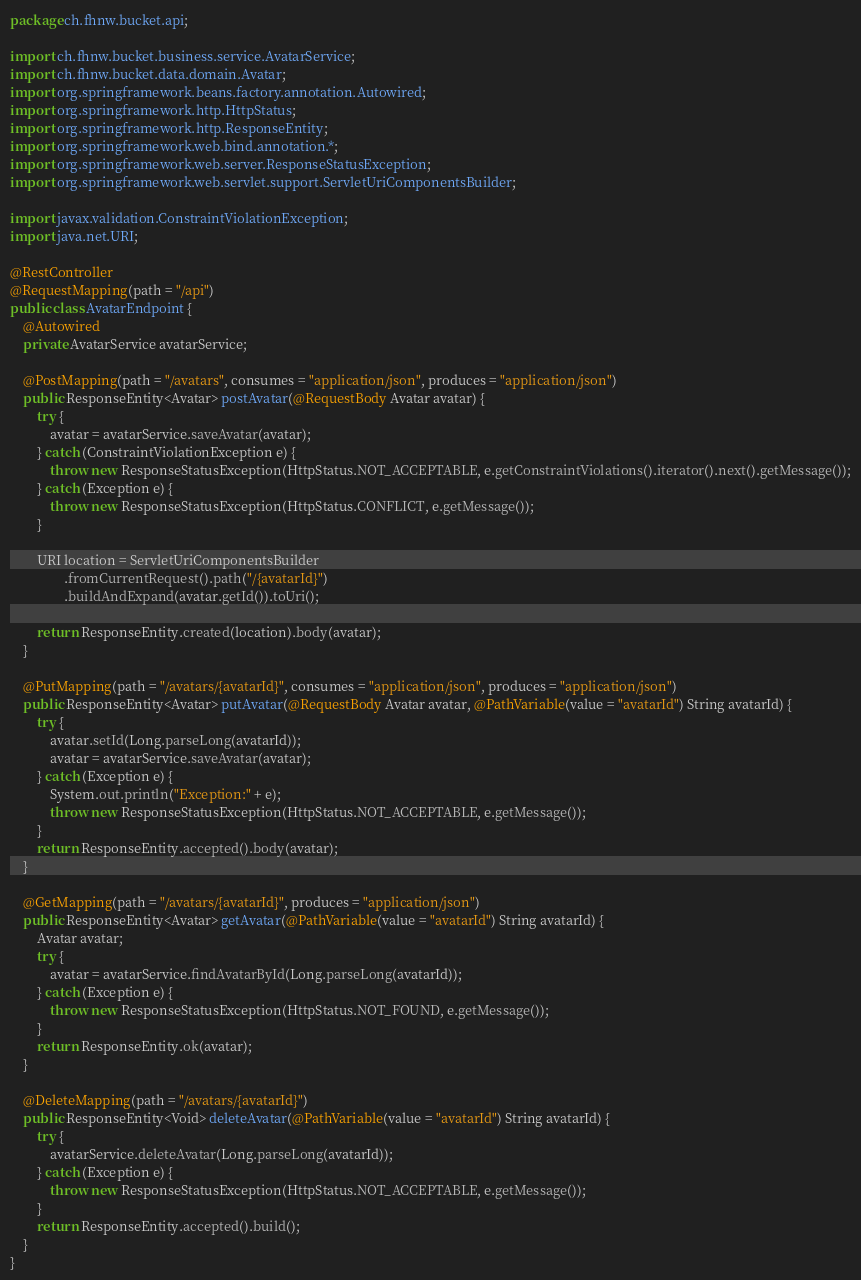<code> <loc_0><loc_0><loc_500><loc_500><_Java_>package ch.fhnw.bucket.api;

import ch.fhnw.bucket.business.service.AvatarService;
import ch.fhnw.bucket.data.domain.Avatar;
import org.springframework.beans.factory.annotation.Autowired;
import org.springframework.http.HttpStatus;
import org.springframework.http.ResponseEntity;
import org.springframework.web.bind.annotation.*;
import org.springframework.web.server.ResponseStatusException;
import org.springframework.web.servlet.support.ServletUriComponentsBuilder;

import javax.validation.ConstraintViolationException;
import java.net.URI;

@RestController
@RequestMapping(path = "/api")
public class AvatarEndpoint {
    @Autowired
    private AvatarService avatarService;

    @PostMapping(path = "/avatars", consumes = "application/json", produces = "application/json")
    public ResponseEntity<Avatar> postAvatar(@RequestBody Avatar avatar) {
        try {
            avatar = avatarService.saveAvatar(avatar);
        } catch (ConstraintViolationException e) {
            throw new ResponseStatusException(HttpStatus.NOT_ACCEPTABLE, e.getConstraintViolations().iterator().next().getMessage());
        } catch (Exception e) {
            throw new ResponseStatusException(HttpStatus.CONFLICT, e.getMessage());
        }

        URI location = ServletUriComponentsBuilder
                .fromCurrentRequest().path("/{avatarId}")
                .buildAndExpand(avatar.getId()).toUri();

        return ResponseEntity.created(location).body(avatar);
    }

    @PutMapping(path = "/avatars/{avatarId}", consumes = "application/json", produces = "application/json")
    public ResponseEntity<Avatar> putAvatar(@RequestBody Avatar avatar, @PathVariable(value = "avatarId") String avatarId) {
        try {
            avatar.setId(Long.parseLong(avatarId));
            avatar = avatarService.saveAvatar(avatar);
        } catch (Exception e) {
            System.out.println("Exception:" + e);
            throw new ResponseStatusException(HttpStatus.NOT_ACCEPTABLE, e.getMessage());
        }
        return ResponseEntity.accepted().body(avatar);
    }

    @GetMapping(path = "/avatars/{avatarId}", produces = "application/json")
    public ResponseEntity<Avatar> getAvatar(@PathVariable(value = "avatarId") String avatarId) {
        Avatar avatar;
        try {
            avatar = avatarService.findAvatarById(Long.parseLong(avatarId));
        } catch (Exception e) {
            throw new ResponseStatusException(HttpStatus.NOT_FOUND, e.getMessage());
        }
        return ResponseEntity.ok(avatar);
    }

    @DeleteMapping(path = "/avatars/{avatarId}")
    public ResponseEntity<Void> deleteAvatar(@PathVariable(value = "avatarId") String avatarId) {
        try {
            avatarService.deleteAvatar(Long.parseLong(avatarId));
        } catch (Exception e) {
            throw new ResponseStatusException(HttpStatus.NOT_ACCEPTABLE, e.getMessage());
        }
        return ResponseEntity.accepted().build();
    }
}</code> 